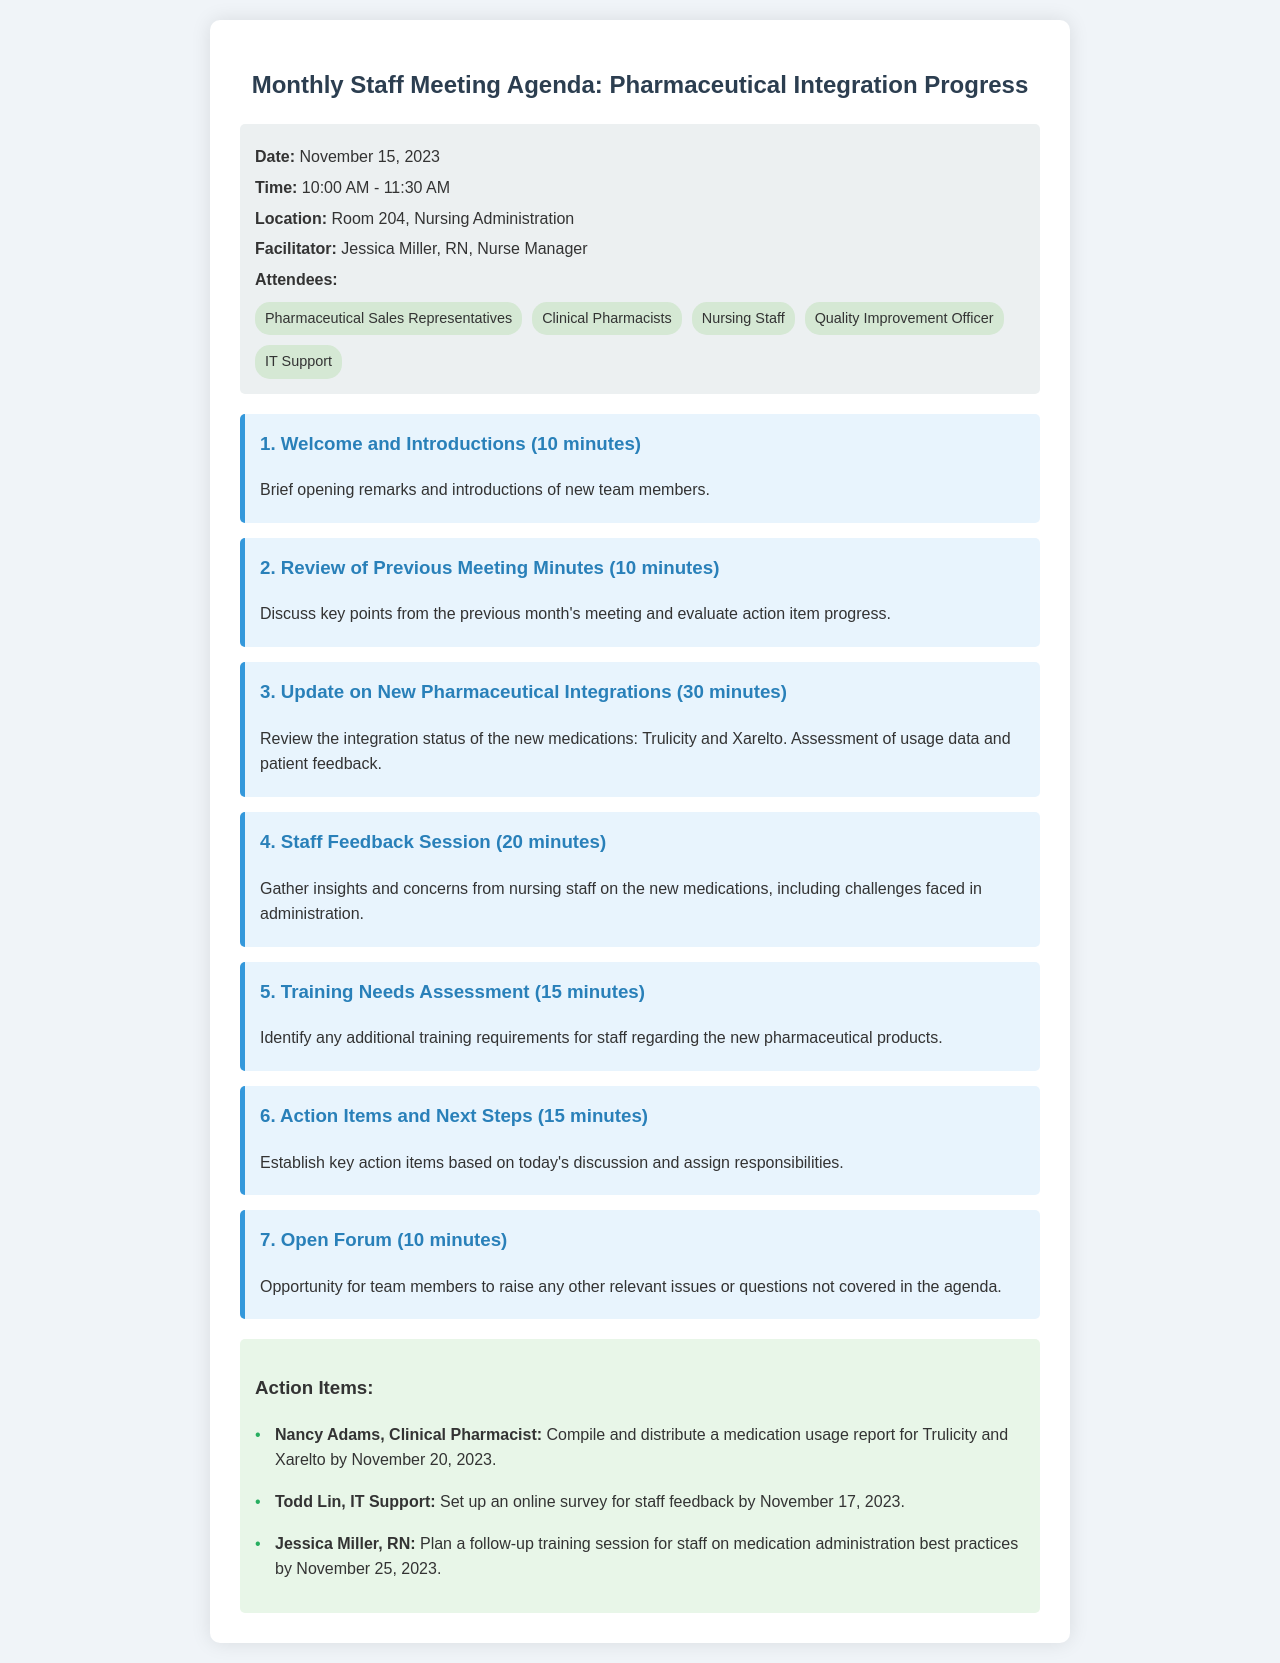What is the meeting date? The meeting date is explicitly stated in the document within the meeting info section.
Answer: November 15, 2023 Who is the facilitator of the meeting? The facilitator's name is provided in the meeting info section under "Facilitator."
Answer: Jessica Miller, RN How long is the "Update on New Pharmaceutical Integrations" scheduled for? The duration of each agenda item is specified, and this particular item is listed with a specific time allocation.
Answer: 30 minutes What medications are being reviewed for integration? The document mentions the specific medications being reviewed in the agenda item related to pharmaceutical integration.
Answer: Trulicity and Xarelto What is one of the action items assigned to Nancy Adams? The action items are listed at the end of the agenda, detailing who is responsible for what task.
Answer: Compile and distribute a medication usage report What will be set up by Todd Lin for feedback? The document specifies the task assigned to Todd Lin in the action items section, which outlines his responsibilities.
Answer: An online survey for staff feedback What is the location of the meeting? The meeting location is mentioned in the meeting info section, detailing where the meeting will take place.
Answer: Room 204, Nursing Administration How many minutes are allocated for the "Open Forum"? Specific timings for each agenda item are provided, including the amount of time for the open forum.
Answer: 10 minutes 